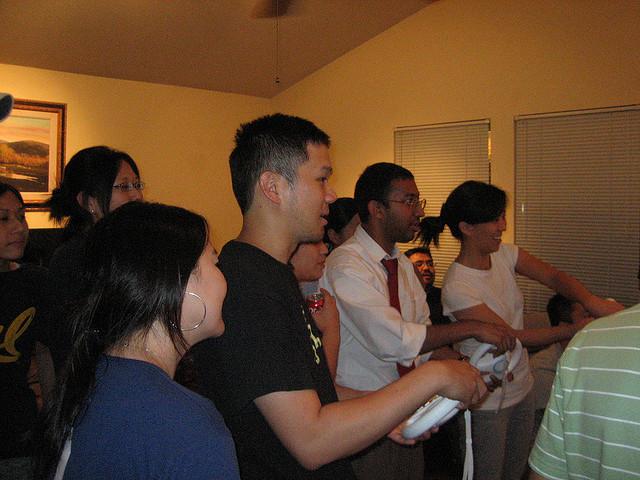How many people are watching?
Answer briefly. 9. Is this a supermarket?
Answer briefly. No. What game are these people playing?
Concise answer only. Wii. Is it a meeting?
Quick response, please. No. What kind of controller are the people holding?
Answer briefly. Wii. What color is the wall?
Concise answer only. White. 